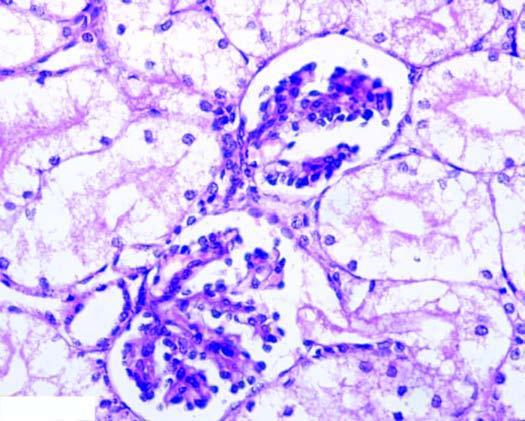what is compressed?
Answer the question using a single word or phrase. Interstitial vasculature 